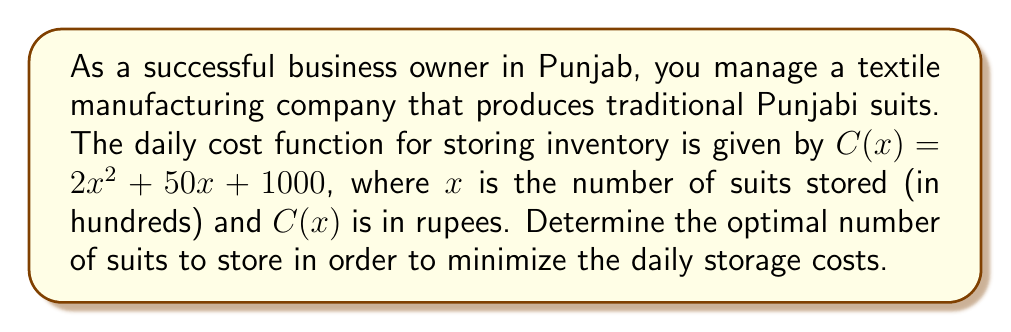Can you answer this question? To find the optimal number of suits to store, we need to minimize the cost function $C(x)$. This can be done by finding the value of $x$ where the derivative of $C(x)$ equals zero.

1) First, let's find the derivative of $C(x)$:
   $$C'(x) = \frac{d}{dx}(2x^2 + 50x + 1000) = 4x + 50$$

2) Now, set the derivative equal to zero and solve for $x$:
   $$4x + 50 = 0$$
   $$4x = -50$$
   $$x = -\frac{50}{4} = -12.5$$

3) Since $x$ represents the number of suits in hundreds, and we can't have a negative number of suits, we need to consider the domain constraints. The minimum possible value for $x$ is 0.

4) To verify that this is indeed a minimum (and not a maximum), we can check the second derivative:
   $$C''(x) = \frac{d}{dx}(4x + 50) = 4$$
   Since $C''(x) > 0$, we confirm that this is a minimum point.

5) Therefore, the optimal number of suits to store is 0, as any positive number of suits will increase the cost.

6) To convert this back to the actual number of suits:
   $0 \times 100 = 0$ suits
Answer: The optimal number of suits to store is 0, which minimizes the daily storage costs. 